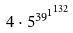Convert formula to latex. <formula><loc_0><loc_0><loc_500><loc_500>4 \cdot 5 ^ { { 3 9 ^ { 1 } } ^ { 1 3 2 } }</formula> 